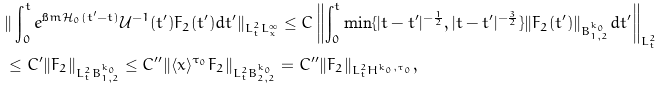<formula> <loc_0><loc_0><loc_500><loc_500>& \| \int _ { 0 } ^ { t } e ^ { \i m \mathcal { H } _ { 0 } ( t ^ { \prime } - t ) } \mathcal { U } ^ { - 1 } ( t ^ { \prime } ) F _ { 2 } ( t ^ { \prime } ) d t ^ { \prime } \| _ { L ^ { 2 } _ { t } L ^ { \infty } _ { x } } \leq C \left \| \int _ { 0 } ^ { t } \min \{ | t - t ^ { \prime } | ^ { - \frac { 1 } { 2 } } , | t - t ^ { \prime } | ^ { - \frac { 3 } { 2 } } \} \| F _ { 2 } ( t ^ { \prime } ) \| _ { B ^ { k _ { 0 } } _ { 1 , 2 } } d t ^ { \prime } \right \| _ { L _ { t } ^ { 2 } } \\ & \leq C ^ { \prime } \| F _ { 2 } \| _ { L ^ { 2 } _ { t } B ^ { k _ { 0 } } _ { 1 , 2 } } \leq C ^ { \prime \prime } \| \langle x \rangle ^ { \tau _ { 0 } } F _ { 2 } \| _ { L ^ { 2 } _ { t } B ^ { k _ { 0 } } _ { 2 , 2 } } = C ^ { \prime \prime } \| F _ { 2 } \| _ { L ^ { 2 } _ { t } H ^ { k _ { 0 } , \tau _ { 0 } } } ,</formula> 